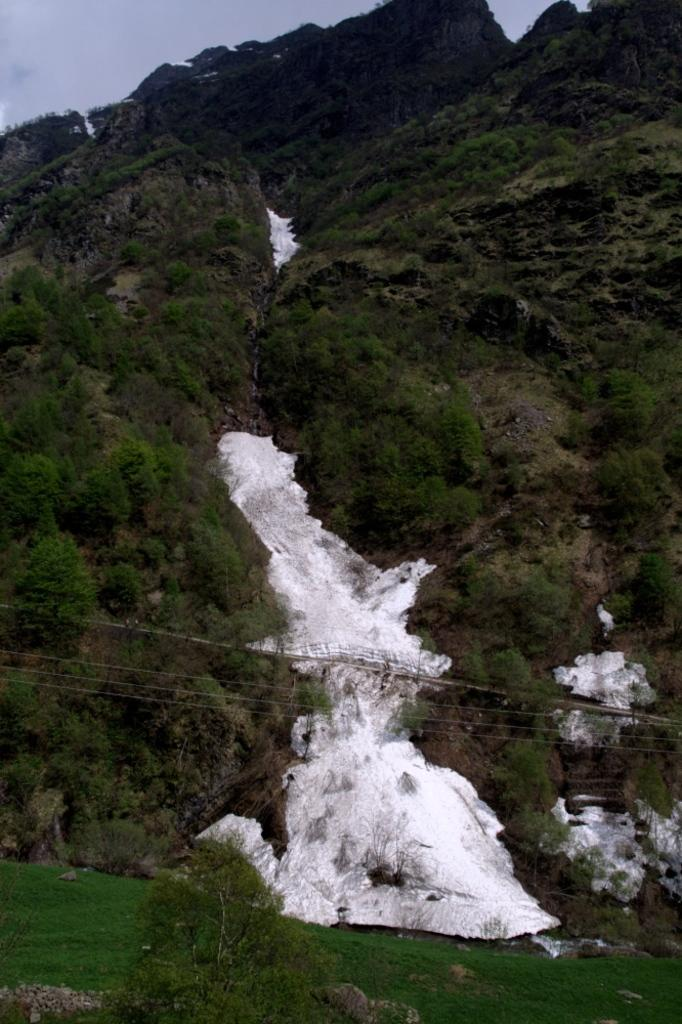What type of vegetation can be seen in the image? There are trees in the image. What is covering the ground in the image? Snow is present on the ground, and grass is also visible. How would you describe the sky in the image? The sky is cloudy in the image. What shape is the worm in the image? There is no worm present in the image. What is the taste of the snow in the image? The image does not provide any information about the taste of the snow, and it is not possible to determine the taste from a visual representation. 